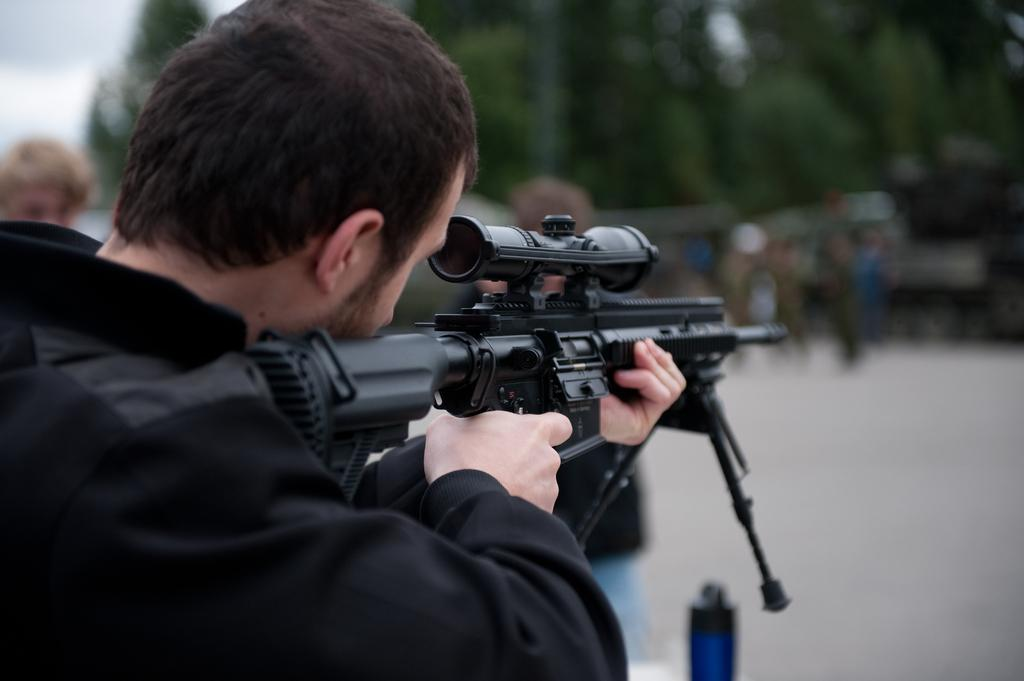What is the main subject of the image? There is a person in the image. What is the person wearing? The person is wearing a black dress. What is the person holding in their hand? The person is holding a black-colored gun in their hand. What can be seen in the background of the image? There are people and trees in the background of the image. What parts of the natural environment are visible in the image? The ground and the sky are visible in the image. What type of cup is the person holding in the image? There is no cup present in the image; the person is holding a black-colored gun. How many eyes does the passenger have in the image? There is no passenger present in the image, and therefore no eyes to count. 